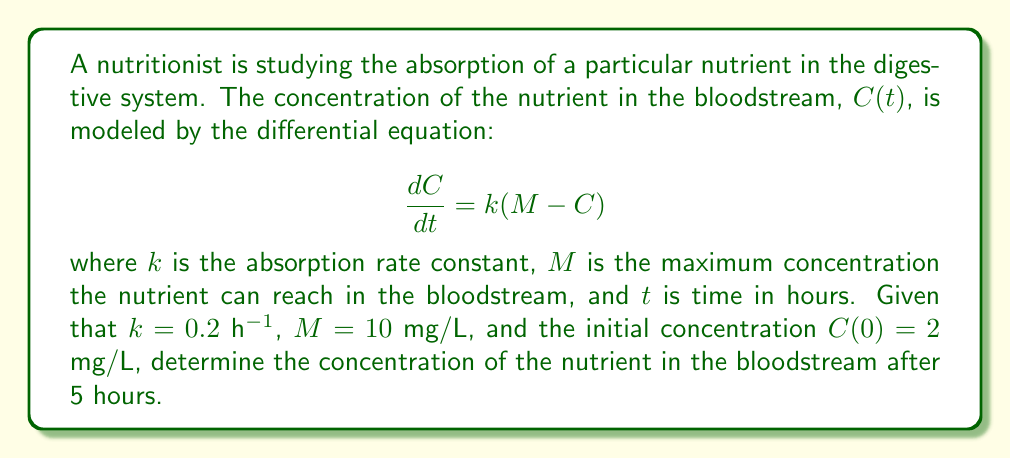Give your solution to this math problem. To solve this problem, we need to follow these steps:

1) First, we recognize this as a first-order linear differential equation.

2) The general solution to this equation is:

   $$C(t) = M + (C_0 - M)e^{-kt}$$

   where $C_0$ is the initial concentration.

3) We're given the following values:
   $k = 0.2$ h⁻¹
   $M = 10$ mg/L
   $C_0 = C(0) = 2$ mg/L
   $t = 5$ h

4) Let's substitute these values into our solution:

   $$C(5) = 10 + (2 - 10)e^{-0.2 \cdot 5}$$

5) Simplify:
   $$C(5) = 10 - 8e^{-1}$$

6) Calculate $e^{-1} \approx 0.3679$:
   $$C(5) = 10 - 8(0.3679) \approx 10 - 2.9432$$

7) Final result:
   $$C(5) \approx 7.0568 \text{ mg/L}$$
Answer: $7.06$ mg/L 